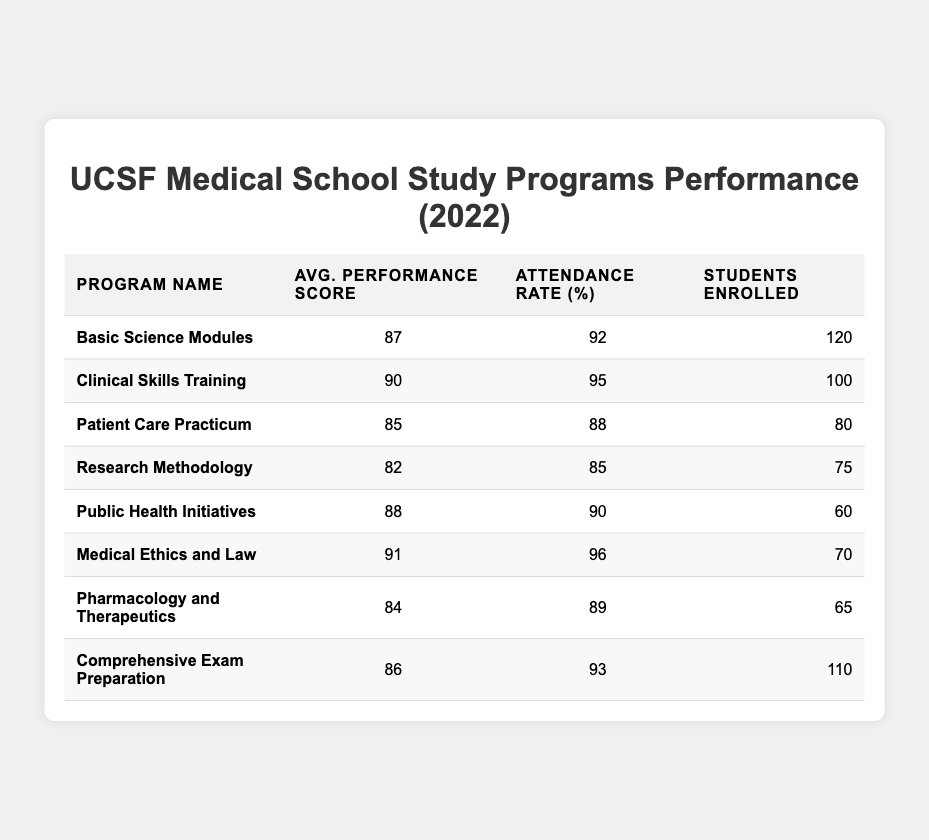What is the average performance score for the Medical Ethics and Law program? The table shows that the average performance score for the Medical Ethics and Law program is listed directly as 91.
Answer: 91 Which study program has the highest attendance rate? The attendance rates of the programs are as follows: Basic Science Modules (92), Clinical Skills Training (95), Patient Care Practicum (88), Research Methodology (85), Public Health Initiatives (90), Medical Ethics and Law (96), Pharmacology and Therapeutics (89), and Comprehensive Exam Preparation (93). The highest is 96 for Medical Ethics and Law.
Answer: Medical Ethics and Law How many students are enrolled in the Patient Care Practicum? The number of students enrolled in the Patient Care Practicum is given as 80 in the table.
Answer: 80 What is the difference between the average performance scores of the Clinical Skills Training and the Research Methodology programs? The performance score for Clinical Skills Training is 90, and for Research Methodology, it is 82. The difference is calculated by subtracting 82 from 90, which equals 8.
Answer: 8 What is the average attendance rate for all study programs? First, we need to sum the attendance rates: 92 + 95 + 88 + 85 + 90 + 96 + 89 + 93 = 718. There are 8 programs, so we calculate the average by dividing the total attendance rate by the number of programs: 718 / 8 = 89.75.
Answer: 89.75 Is the average performance score of the Public Health Initiatives program above the average performance score of the Pharmacology and Therapeutics program? The average performance score for Public Health Initiatives is 88, and for Pharmacology and Therapeutics, it is 84. Since 88 is greater than 84, the statement is true.
Answer: Yes Which program has the lowest number of students enrolled, and what is that number? Looking at the table, the program with the lowest number of students enrolled is Public Health Initiatives with 60 students.
Answer: Public Health Initiatives, 60 What is the combined total number of students enrolled in Comprehensive Exam Preparation and Patient Care Practicum? The number of students in Comprehensive Exam Preparation is 110, and in Patient Care Practicum, it is 80. Adding these, 110 + 80 = 190, gives the total number of students enrolled in both programs.
Answer: 190 Are there any study programs with an average performance score of 85 or lower? The programs with scores are: Basic Science Modules (87), Clinical Skills Training (90), Patient Care Practicum (85), Research Methodology (82), Public Health Initiatives (88), Medical Ethics and Law (91), Pharmacology and Therapeutics (84), and Comprehensive Exam Preparation (86). The scores 85 or lower are from Patient Care Practicum (85), Research Methodology (82), and Pharmacology and Therapeutics (84), so there are such programs.
Answer: Yes What is the median attendance rate among all the study programs? First, arrange the attendance rates from lowest to highest: 85, 88, 89, 90, 92, 93, 95, 96. There are 8 values. The median is the average of the 4th and 5th values: (90 + 92) / 2 = 91.
Answer: 91 